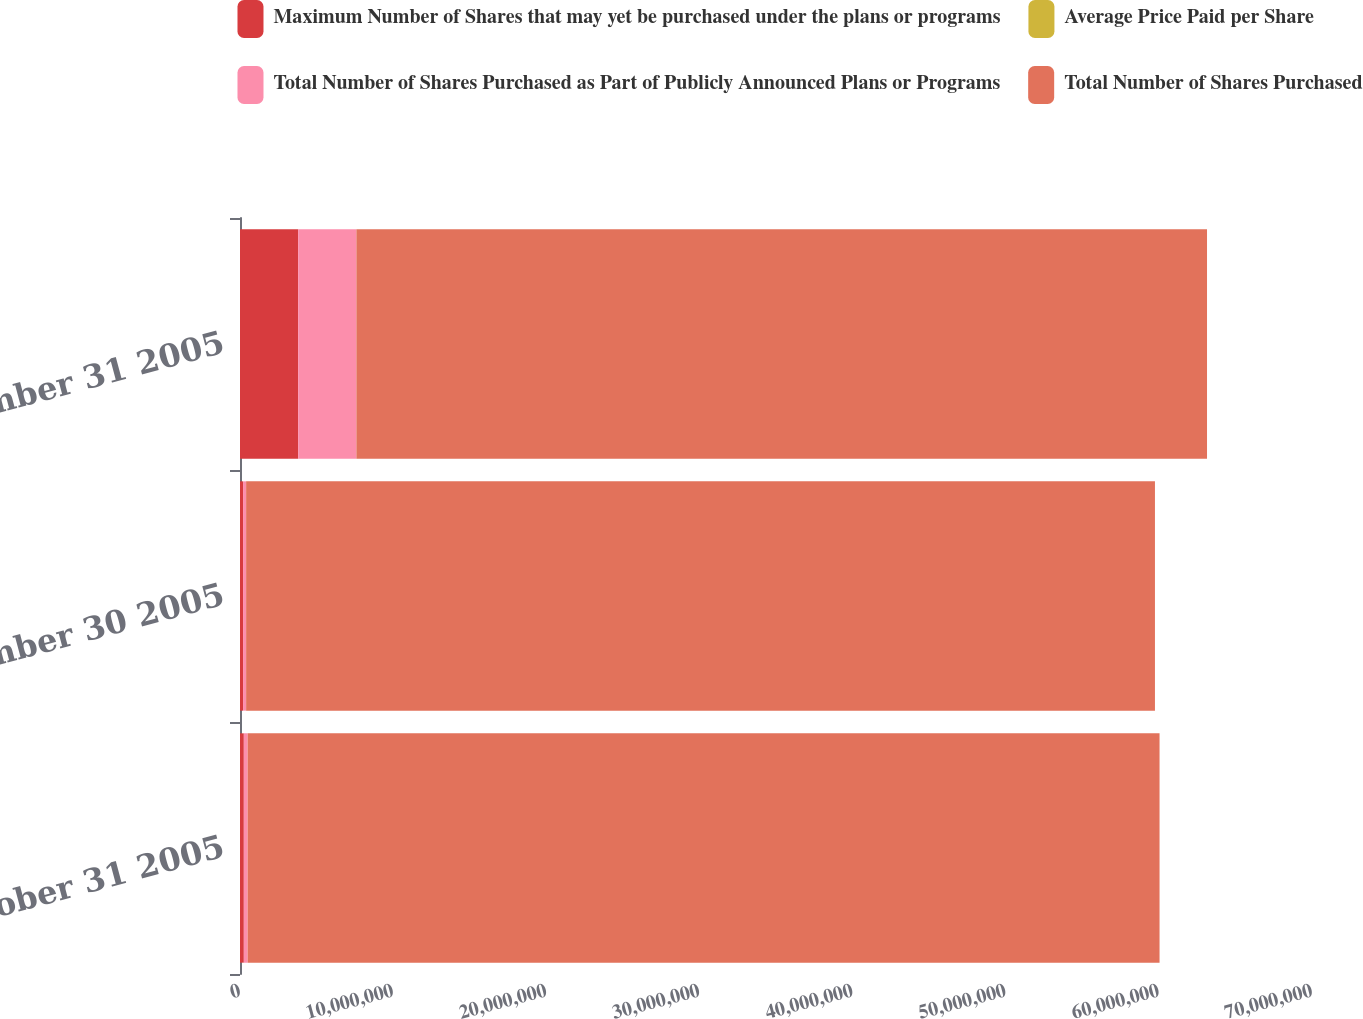<chart> <loc_0><loc_0><loc_500><loc_500><stacked_bar_chart><ecel><fcel>October 31 2005<fcel>November 30 2005<fcel>December 31 2005<nl><fcel>Maximum Number of Shares that may yet be purchased under the plans or programs<fcel>250000<fcel>200000<fcel>3.8e+06<nl><fcel>Average Price Paid per Share<fcel>56.5<fcel>60.4<fcel>63.31<nl><fcel>Total Number of Shares Purchased as Part of Publicly Announced Plans or Programs<fcel>250000<fcel>200000<fcel>3.8e+06<nl><fcel>Total Number of Shares Purchased<fcel>5.95451e+07<fcel>5.93451e+07<fcel>5.55451e+07<nl></chart> 